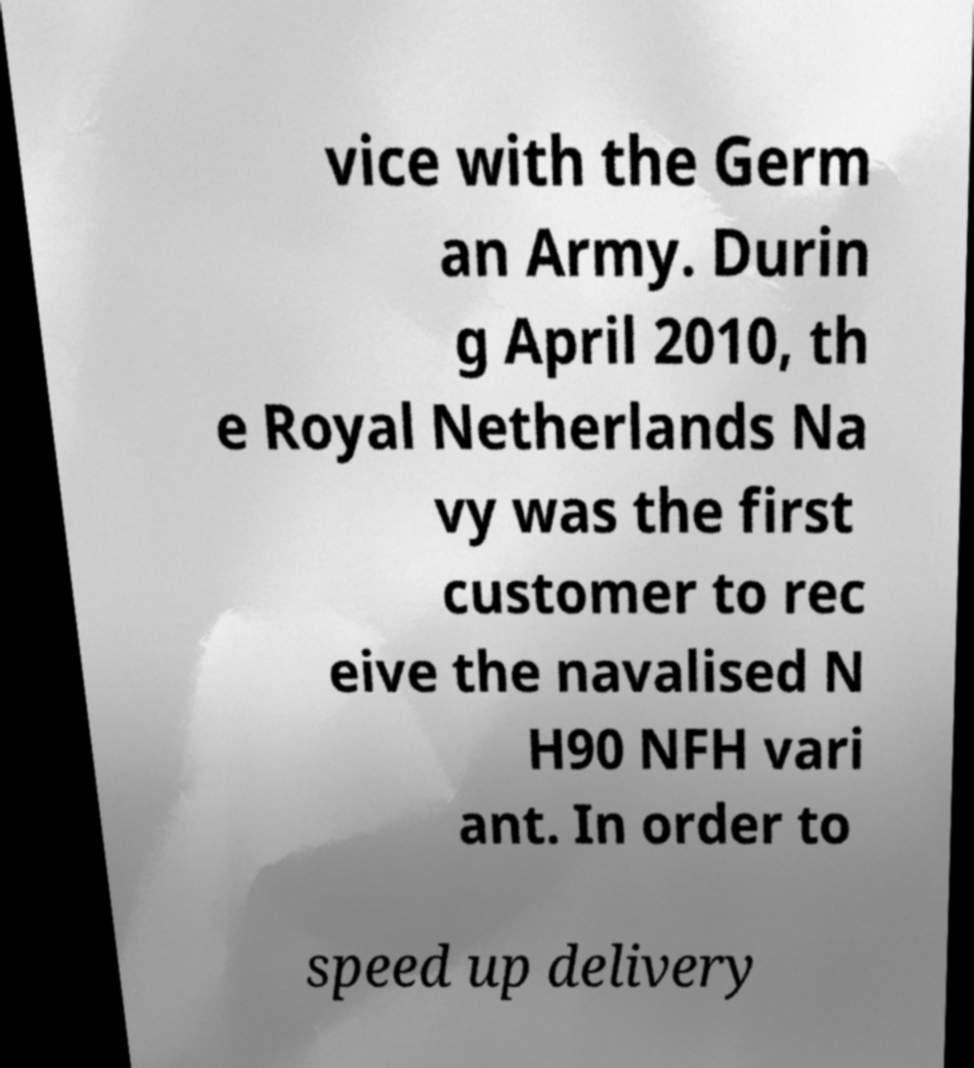Can you read and provide the text displayed in the image?This photo seems to have some interesting text. Can you extract and type it out for me? vice with the Germ an Army. Durin g April 2010, th e Royal Netherlands Na vy was the first customer to rec eive the navalised N H90 NFH vari ant. In order to speed up delivery 